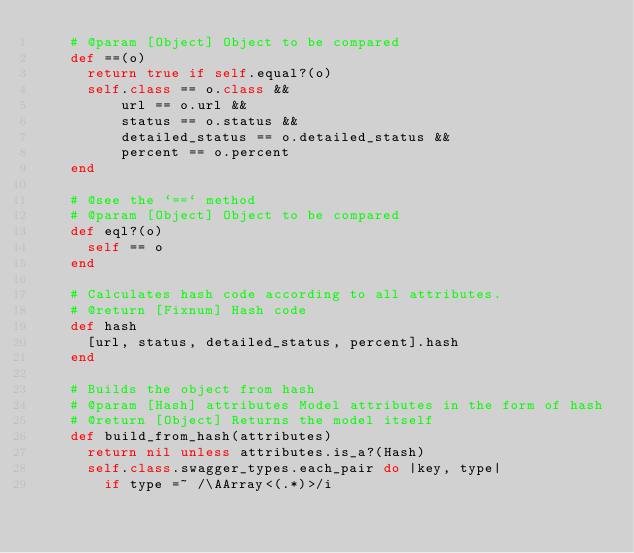<code> <loc_0><loc_0><loc_500><loc_500><_Ruby_>    # @param [Object] Object to be compared
    def ==(o)
      return true if self.equal?(o)
      self.class == o.class &&
          url == o.url &&
          status == o.status &&
          detailed_status == o.detailed_status &&
          percent == o.percent
    end

    # @see the `==` method
    # @param [Object] Object to be compared
    def eql?(o)
      self == o
    end

    # Calculates hash code according to all attributes.
    # @return [Fixnum] Hash code
    def hash
      [url, status, detailed_status, percent].hash
    end

    # Builds the object from hash
    # @param [Hash] attributes Model attributes in the form of hash
    # @return [Object] Returns the model itself
    def build_from_hash(attributes)
      return nil unless attributes.is_a?(Hash)
      self.class.swagger_types.each_pair do |key, type|
        if type =~ /\AArray<(.*)>/i</code> 